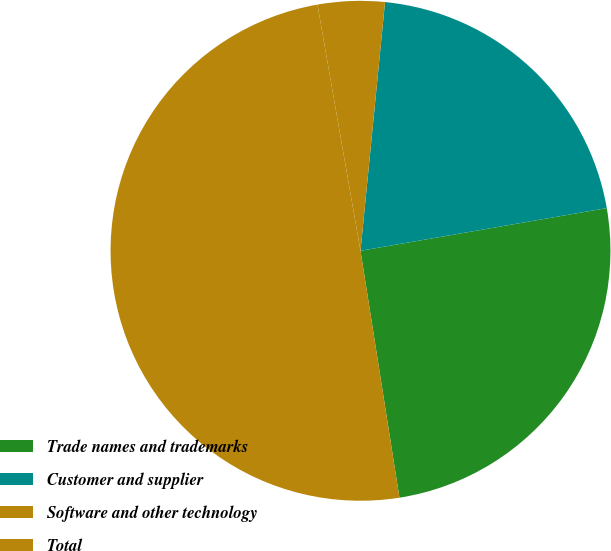Convert chart to OTSL. <chart><loc_0><loc_0><loc_500><loc_500><pie_chart><fcel>Trade names and trademarks<fcel>Customer and supplier<fcel>Software and other technology<fcel>Total<nl><fcel>25.24%<fcel>20.7%<fcel>4.32%<fcel>49.73%<nl></chart> 